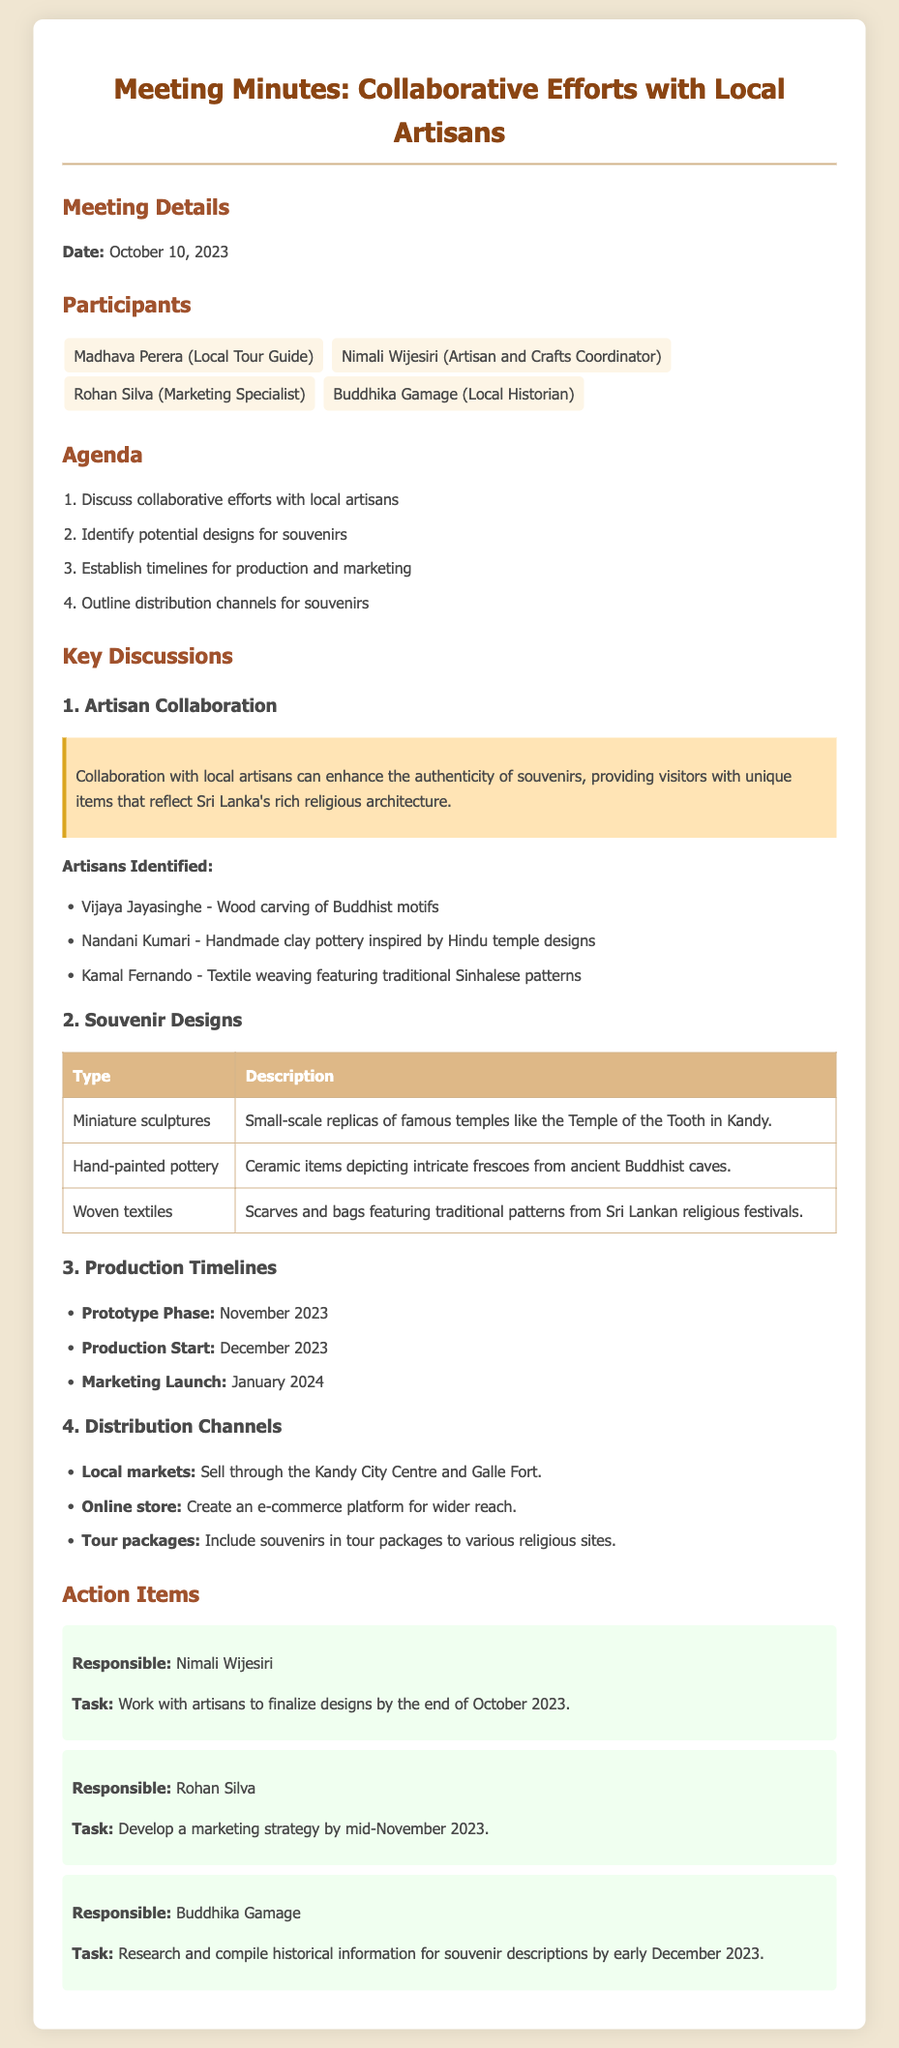what is the date of the meeting? The meeting was held on October 10, 2023.
Answer: October 10, 2023 who is the artisan identified for wood carving? The artisan identified for wood carving is Vijaya Jayasinghe.
Answer: Vijaya Jayasinghe what is the prototype phase target date? The prototype phase is scheduled for November 2023.
Answer: November 2023 which type of souvenir involves handmade clay pottery? Handmade clay pottery is inspired by Hindu temple designs.
Answer: Nandani Kumari how many participants were in the meeting? There were four participants listed for the meeting.
Answer: Four what is Rohan Silva responsible for? Rohan Silva is responsible for developing a marketing strategy.
Answer: Developing a marketing strategy when is the production start date for souvenirs? The production start date is set for December 2023.
Answer: December 2023 what type of products will be included in tour packages? The tour packages will include souvenirs reflecting religious architecture.
Answer: Souvenirs 